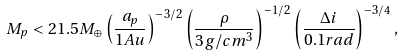<formula> <loc_0><loc_0><loc_500><loc_500>M _ { p } < 2 1 . 5 M _ { \oplus } \left ( \frac { a _ { p } } { 1 A u } \right ) ^ { - 3 / 2 } \left ( \frac { \rho } { 3 g / c m ^ { 3 } } \right ) ^ { - 1 / 2 } \left ( \frac { \Delta i } { 0 . 1 r a d } \right ) ^ { - 3 / 4 } ,</formula> 